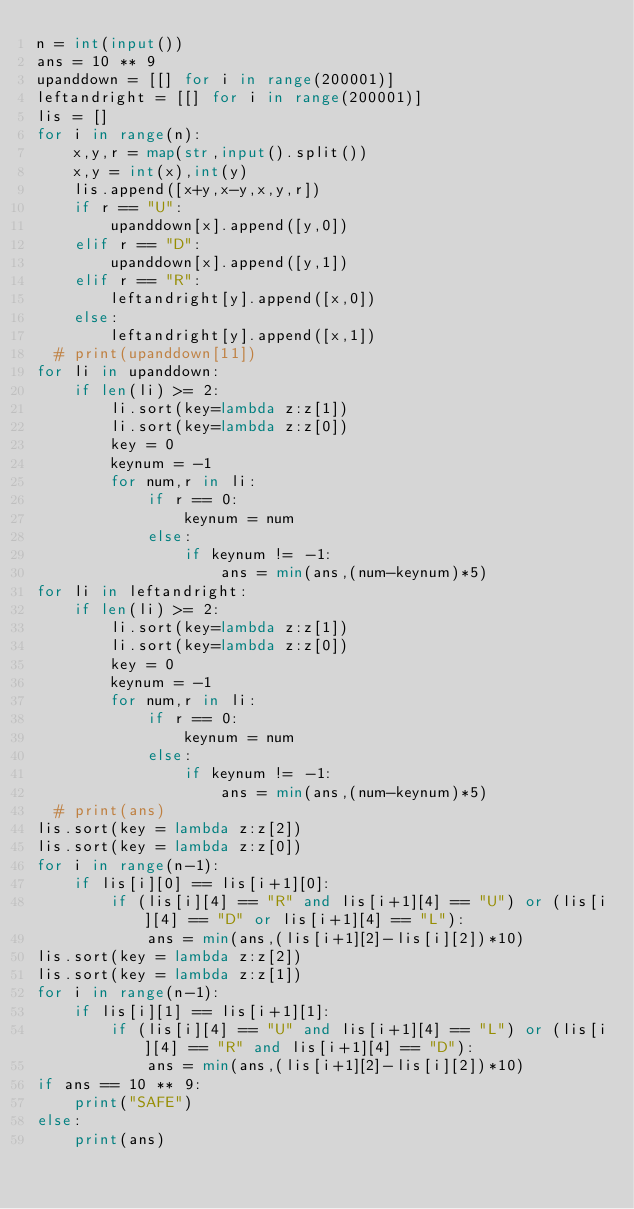<code> <loc_0><loc_0><loc_500><loc_500><_Python_>n = int(input())
ans = 10 ** 9
upanddown = [[] for i in range(200001)]
leftandright = [[] for i in range(200001)]
lis = []
for i in range(n):
    x,y,r = map(str,input().split())
    x,y = int(x),int(y)
    lis.append([x+y,x-y,x,y,r])
    if r == "U":
        upanddown[x].append([y,0])
    elif r == "D":
        upanddown[x].append([y,1])
    elif r == "R":
        leftandright[y].append([x,0])
    else:
        leftandright[y].append([x,1])
  # print(upanddown[11])
for li in upanddown:
    if len(li) >= 2:
        li.sort(key=lambda z:z[1])
        li.sort(key=lambda z:z[0])
        key = 0
        keynum = -1
        for num,r in li:
            if r == 0:
                keynum = num
            else:
                if keynum != -1:
                    ans = min(ans,(num-keynum)*5)
for li in leftandright:
    if len(li) >= 2:
        li.sort(key=lambda z:z[1])
        li.sort(key=lambda z:z[0])
        key = 0
        keynum = -1
        for num,r in li:
            if r == 0:
                keynum = num
            else:
                if keynum != -1:
                    ans = min(ans,(num-keynum)*5)
  # print(ans)
lis.sort(key = lambda z:z[2])
lis.sort(key = lambda z:z[0])
for i in range(n-1):
    if lis[i][0] == lis[i+1][0]:
        if (lis[i][4] == "R" and lis[i+1][4] == "U") or (lis[i][4] == "D" or lis[i+1][4] == "L"):
            ans = min(ans,(lis[i+1][2]-lis[i][2])*10)
lis.sort(key = lambda z:z[2])
lis.sort(key = lambda z:z[1])
for i in range(n-1):
    if lis[i][1] == lis[i+1][1]:
        if (lis[i][4] == "U" and lis[i+1][4] == "L") or (lis[i][4] == "R" and lis[i+1][4] == "D"):
            ans = min(ans,(lis[i+1][2]-lis[i][2])*10)
if ans == 10 ** 9:
    print("SAFE")
else:
    print(ans)</code> 